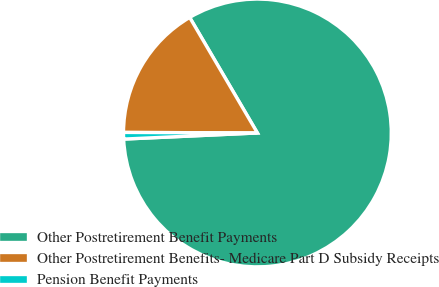Convert chart to OTSL. <chart><loc_0><loc_0><loc_500><loc_500><pie_chart><fcel>Other Postretirement Benefit Payments<fcel>Other Postretirement Benefits- Medicare Part D Subsidy Receipts<fcel>Pension Benefit Payments<nl><fcel>82.71%<fcel>16.5%<fcel>0.79%<nl></chart> 